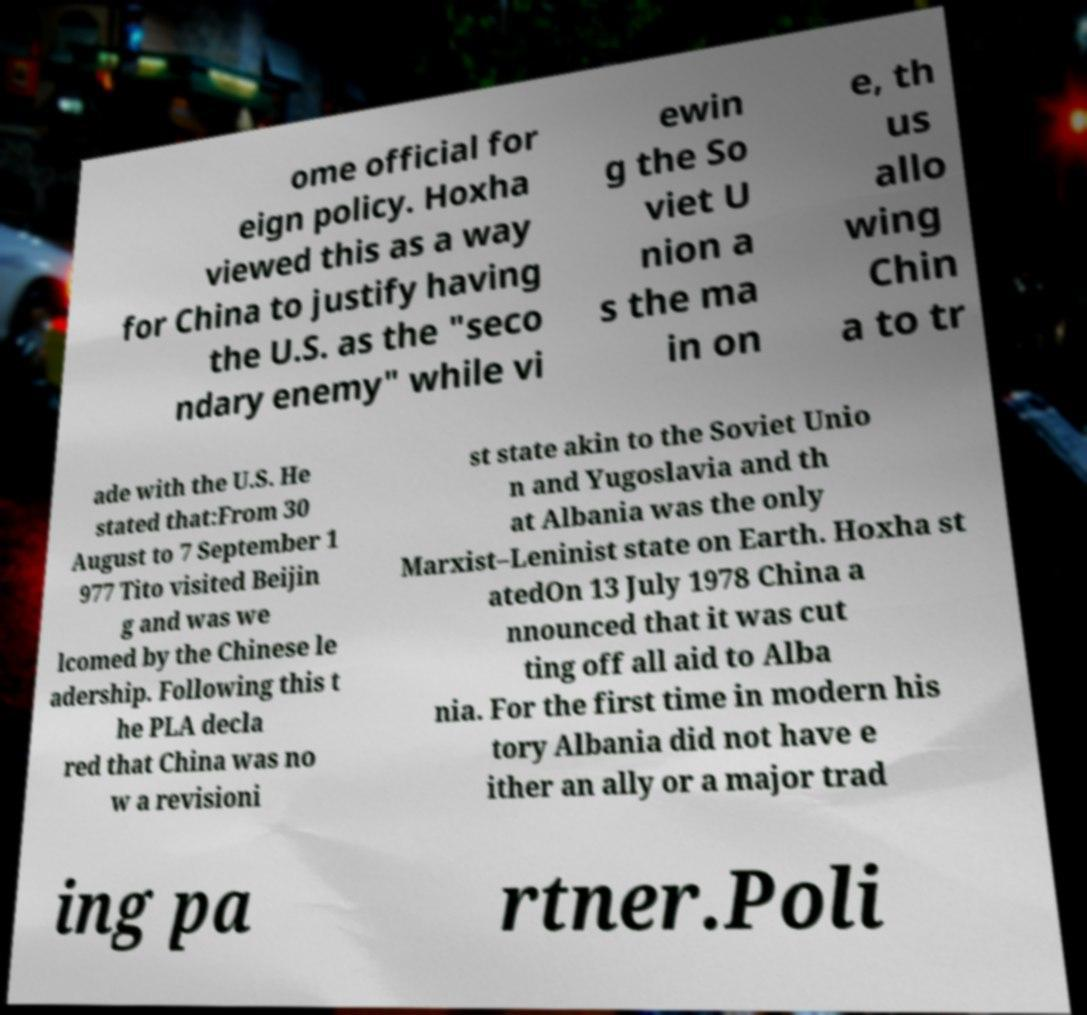Please read and relay the text visible in this image. What does it say? ome official for eign policy. Hoxha viewed this as a way for China to justify having the U.S. as the "seco ndary enemy" while vi ewin g the So viet U nion a s the ma in on e, th us allo wing Chin a to tr ade with the U.S. He stated that:From 30 August to 7 September 1 977 Tito visited Beijin g and was we lcomed by the Chinese le adership. Following this t he PLA decla red that China was no w a revisioni st state akin to the Soviet Unio n and Yugoslavia and th at Albania was the only Marxist–Leninist state on Earth. Hoxha st atedOn 13 July 1978 China a nnounced that it was cut ting off all aid to Alba nia. For the first time in modern his tory Albania did not have e ither an ally or a major trad ing pa rtner.Poli 